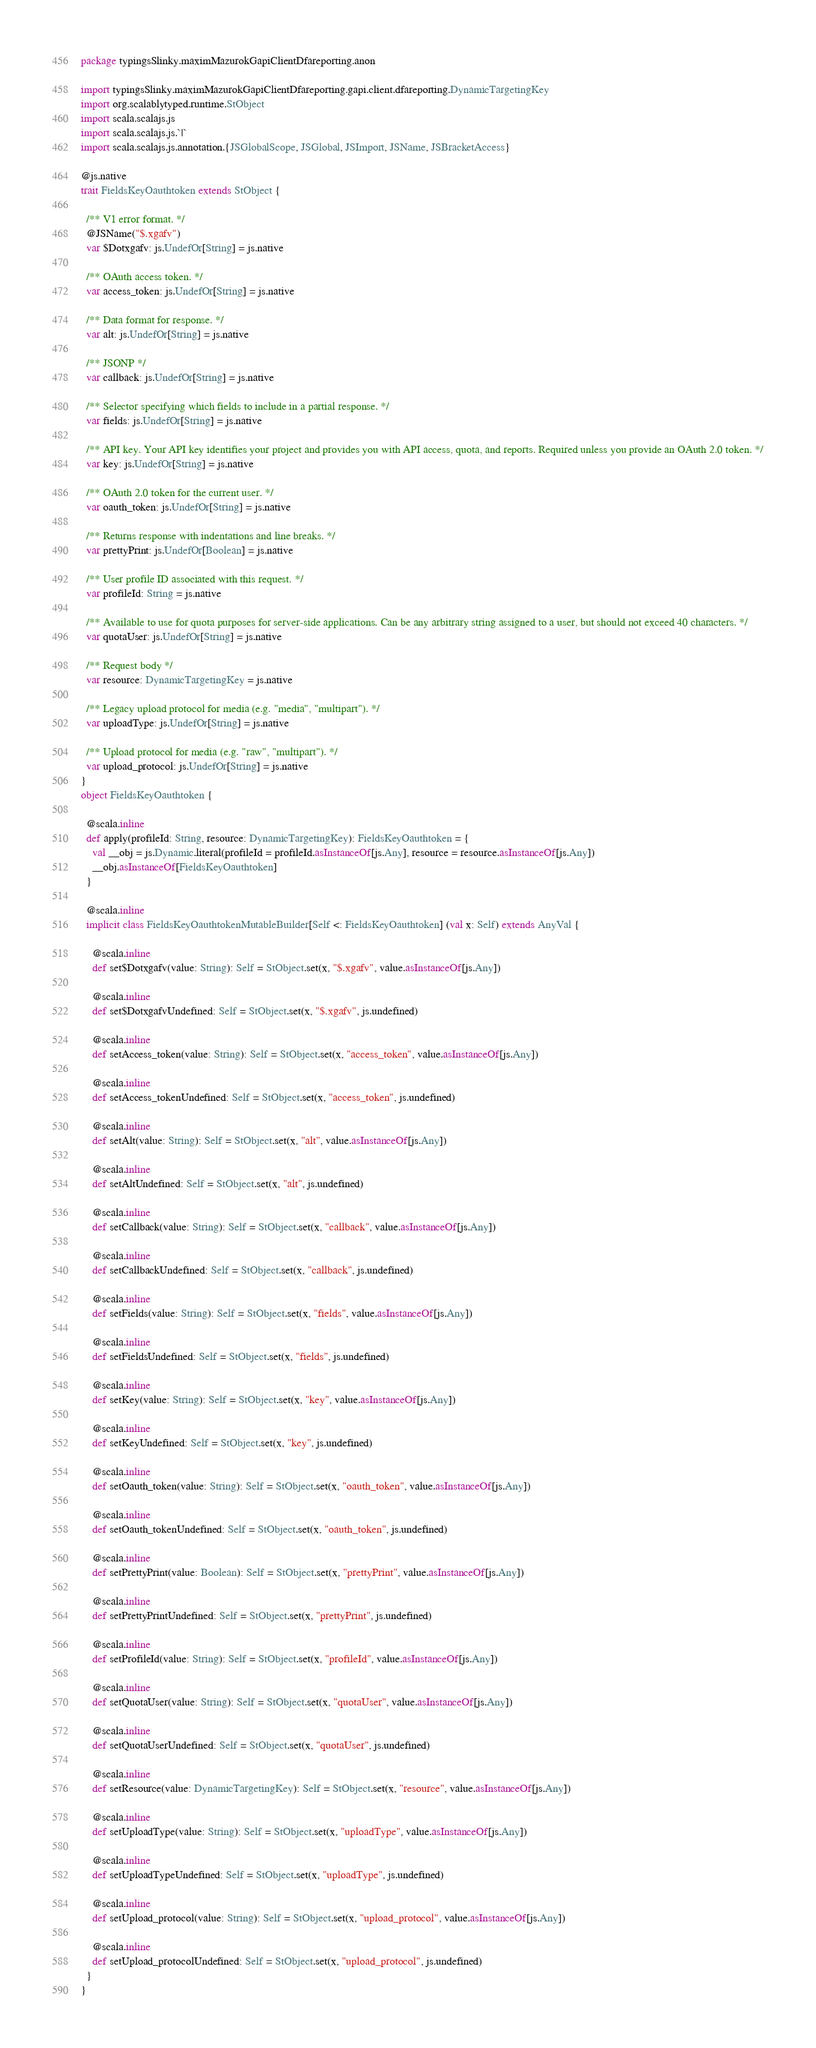Convert code to text. <code><loc_0><loc_0><loc_500><loc_500><_Scala_>package typingsSlinky.maximMazurokGapiClientDfareporting.anon

import typingsSlinky.maximMazurokGapiClientDfareporting.gapi.client.dfareporting.DynamicTargetingKey
import org.scalablytyped.runtime.StObject
import scala.scalajs.js
import scala.scalajs.js.`|`
import scala.scalajs.js.annotation.{JSGlobalScope, JSGlobal, JSImport, JSName, JSBracketAccess}

@js.native
trait FieldsKeyOauthtoken extends StObject {
  
  /** V1 error format. */
  @JSName("$.xgafv")
  var $Dotxgafv: js.UndefOr[String] = js.native
  
  /** OAuth access token. */
  var access_token: js.UndefOr[String] = js.native
  
  /** Data format for response. */
  var alt: js.UndefOr[String] = js.native
  
  /** JSONP */
  var callback: js.UndefOr[String] = js.native
  
  /** Selector specifying which fields to include in a partial response. */
  var fields: js.UndefOr[String] = js.native
  
  /** API key. Your API key identifies your project and provides you with API access, quota, and reports. Required unless you provide an OAuth 2.0 token. */
  var key: js.UndefOr[String] = js.native
  
  /** OAuth 2.0 token for the current user. */
  var oauth_token: js.UndefOr[String] = js.native
  
  /** Returns response with indentations and line breaks. */
  var prettyPrint: js.UndefOr[Boolean] = js.native
  
  /** User profile ID associated with this request. */
  var profileId: String = js.native
  
  /** Available to use for quota purposes for server-side applications. Can be any arbitrary string assigned to a user, but should not exceed 40 characters. */
  var quotaUser: js.UndefOr[String] = js.native
  
  /** Request body */
  var resource: DynamicTargetingKey = js.native
  
  /** Legacy upload protocol for media (e.g. "media", "multipart"). */
  var uploadType: js.UndefOr[String] = js.native
  
  /** Upload protocol for media (e.g. "raw", "multipart"). */
  var upload_protocol: js.UndefOr[String] = js.native
}
object FieldsKeyOauthtoken {
  
  @scala.inline
  def apply(profileId: String, resource: DynamicTargetingKey): FieldsKeyOauthtoken = {
    val __obj = js.Dynamic.literal(profileId = profileId.asInstanceOf[js.Any], resource = resource.asInstanceOf[js.Any])
    __obj.asInstanceOf[FieldsKeyOauthtoken]
  }
  
  @scala.inline
  implicit class FieldsKeyOauthtokenMutableBuilder[Self <: FieldsKeyOauthtoken] (val x: Self) extends AnyVal {
    
    @scala.inline
    def set$Dotxgafv(value: String): Self = StObject.set(x, "$.xgafv", value.asInstanceOf[js.Any])
    
    @scala.inline
    def set$DotxgafvUndefined: Self = StObject.set(x, "$.xgafv", js.undefined)
    
    @scala.inline
    def setAccess_token(value: String): Self = StObject.set(x, "access_token", value.asInstanceOf[js.Any])
    
    @scala.inline
    def setAccess_tokenUndefined: Self = StObject.set(x, "access_token", js.undefined)
    
    @scala.inline
    def setAlt(value: String): Self = StObject.set(x, "alt", value.asInstanceOf[js.Any])
    
    @scala.inline
    def setAltUndefined: Self = StObject.set(x, "alt", js.undefined)
    
    @scala.inline
    def setCallback(value: String): Self = StObject.set(x, "callback", value.asInstanceOf[js.Any])
    
    @scala.inline
    def setCallbackUndefined: Self = StObject.set(x, "callback", js.undefined)
    
    @scala.inline
    def setFields(value: String): Self = StObject.set(x, "fields", value.asInstanceOf[js.Any])
    
    @scala.inline
    def setFieldsUndefined: Self = StObject.set(x, "fields", js.undefined)
    
    @scala.inline
    def setKey(value: String): Self = StObject.set(x, "key", value.asInstanceOf[js.Any])
    
    @scala.inline
    def setKeyUndefined: Self = StObject.set(x, "key", js.undefined)
    
    @scala.inline
    def setOauth_token(value: String): Self = StObject.set(x, "oauth_token", value.asInstanceOf[js.Any])
    
    @scala.inline
    def setOauth_tokenUndefined: Self = StObject.set(x, "oauth_token", js.undefined)
    
    @scala.inline
    def setPrettyPrint(value: Boolean): Self = StObject.set(x, "prettyPrint", value.asInstanceOf[js.Any])
    
    @scala.inline
    def setPrettyPrintUndefined: Self = StObject.set(x, "prettyPrint", js.undefined)
    
    @scala.inline
    def setProfileId(value: String): Self = StObject.set(x, "profileId", value.asInstanceOf[js.Any])
    
    @scala.inline
    def setQuotaUser(value: String): Self = StObject.set(x, "quotaUser", value.asInstanceOf[js.Any])
    
    @scala.inline
    def setQuotaUserUndefined: Self = StObject.set(x, "quotaUser", js.undefined)
    
    @scala.inline
    def setResource(value: DynamicTargetingKey): Self = StObject.set(x, "resource", value.asInstanceOf[js.Any])
    
    @scala.inline
    def setUploadType(value: String): Self = StObject.set(x, "uploadType", value.asInstanceOf[js.Any])
    
    @scala.inline
    def setUploadTypeUndefined: Self = StObject.set(x, "uploadType", js.undefined)
    
    @scala.inline
    def setUpload_protocol(value: String): Self = StObject.set(x, "upload_protocol", value.asInstanceOf[js.Any])
    
    @scala.inline
    def setUpload_protocolUndefined: Self = StObject.set(x, "upload_protocol", js.undefined)
  }
}
</code> 